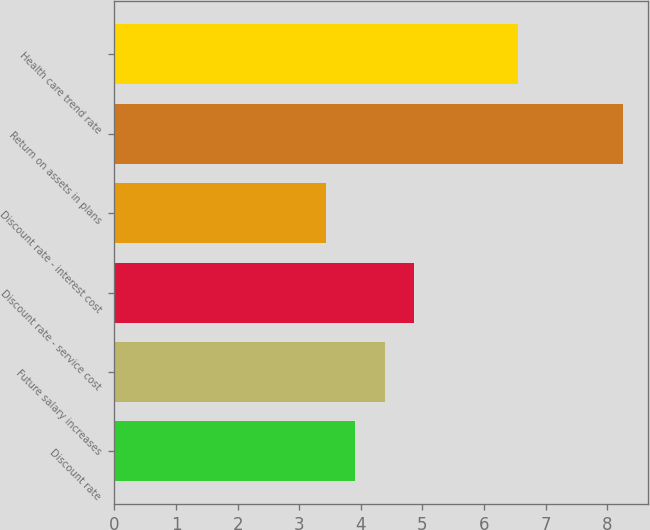Convert chart. <chart><loc_0><loc_0><loc_500><loc_500><bar_chart><fcel>Discount rate<fcel>Future salary increases<fcel>Discount rate - service cost<fcel>Discount rate - interest cost<fcel>Return on assets in plans<fcel>Health care trend rate<nl><fcel>3.91<fcel>4.39<fcel>4.87<fcel>3.43<fcel>8.25<fcel>6.56<nl></chart> 